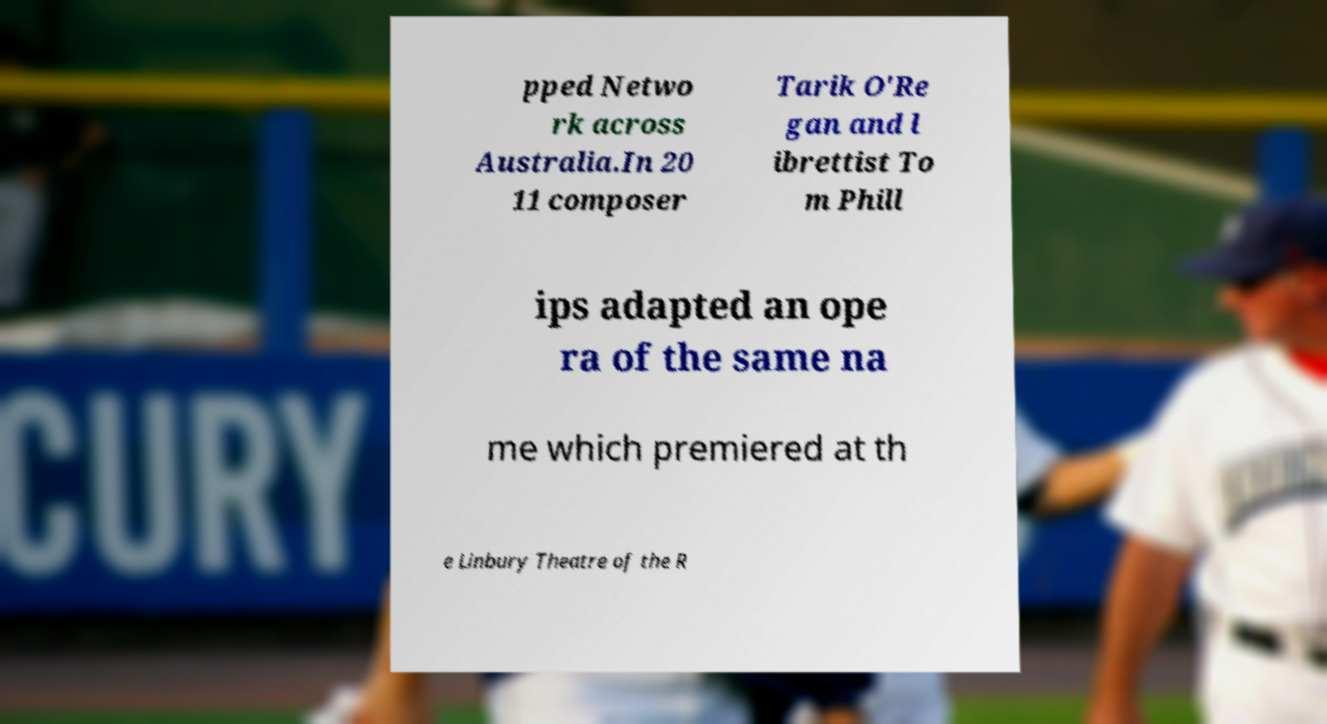Could you assist in decoding the text presented in this image and type it out clearly? pped Netwo rk across Australia.In 20 11 composer Tarik O'Re gan and l ibrettist To m Phill ips adapted an ope ra of the same na me which premiered at th e Linbury Theatre of the R 